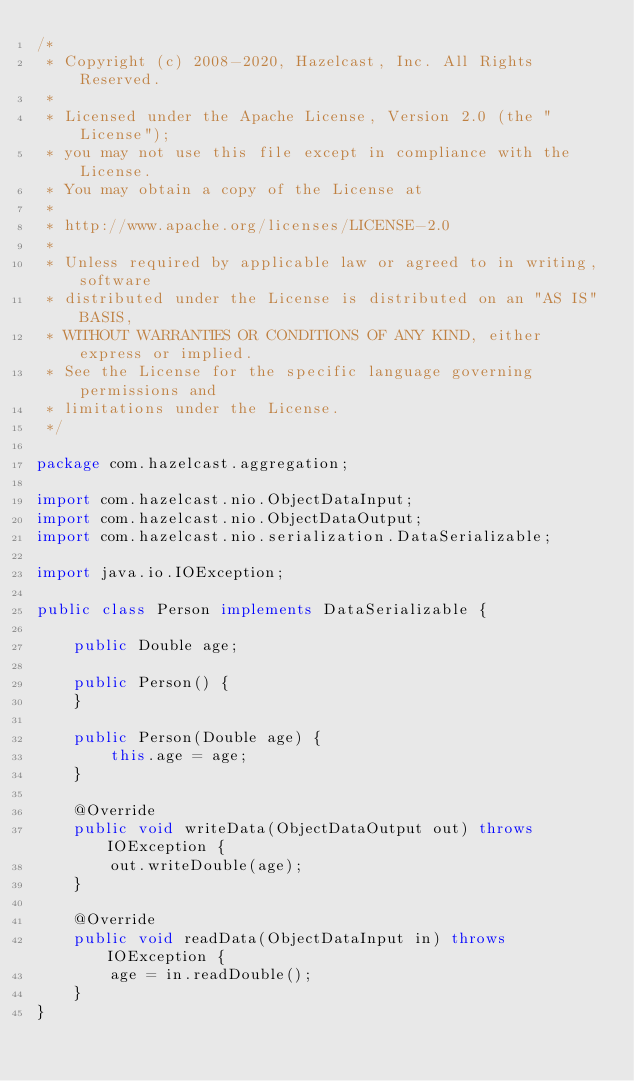Convert code to text. <code><loc_0><loc_0><loc_500><loc_500><_Java_>/*
 * Copyright (c) 2008-2020, Hazelcast, Inc. All Rights Reserved.
 *
 * Licensed under the Apache License, Version 2.0 (the "License");
 * you may not use this file except in compliance with the License.
 * You may obtain a copy of the License at
 *
 * http://www.apache.org/licenses/LICENSE-2.0
 *
 * Unless required by applicable law or agreed to in writing, software
 * distributed under the License is distributed on an "AS IS" BASIS,
 * WITHOUT WARRANTIES OR CONDITIONS OF ANY KIND, either express or implied.
 * See the License for the specific language governing permissions and
 * limitations under the License.
 */

package com.hazelcast.aggregation;

import com.hazelcast.nio.ObjectDataInput;
import com.hazelcast.nio.ObjectDataOutput;
import com.hazelcast.nio.serialization.DataSerializable;

import java.io.IOException;

public class Person implements DataSerializable {

    public Double age;

    public Person() {
    }

    public Person(Double age) {
        this.age = age;
    }

    @Override
    public void writeData(ObjectDataOutput out) throws IOException {
        out.writeDouble(age);
    }

    @Override
    public void readData(ObjectDataInput in) throws IOException {
        age = in.readDouble();
    }
}
</code> 